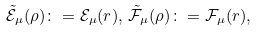Convert formula to latex. <formula><loc_0><loc_0><loc_500><loc_500>\tilde { \mathcal { E } } _ { \mu } ( \rho ) \colon = \mathcal { E } _ { \mu } ( r ) , \, \tilde { \mathcal { F } } _ { \mu } ( \rho ) \colon = \mathcal { F } _ { \mu } ( r ) ,</formula> 